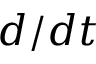Convert formula to latex. <formula><loc_0><loc_0><loc_500><loc_500>d / d t</formula> 